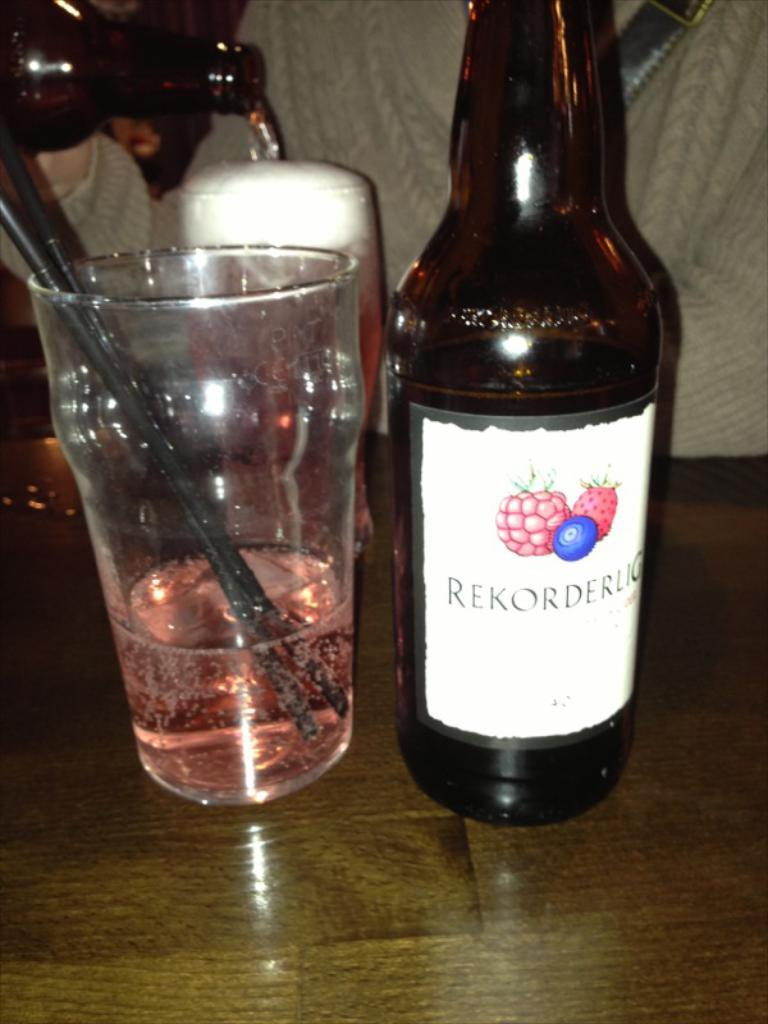<image>
Offer a succinct explanation of the picture presented. A bottle of Rekorderlig has fruit on the label. 